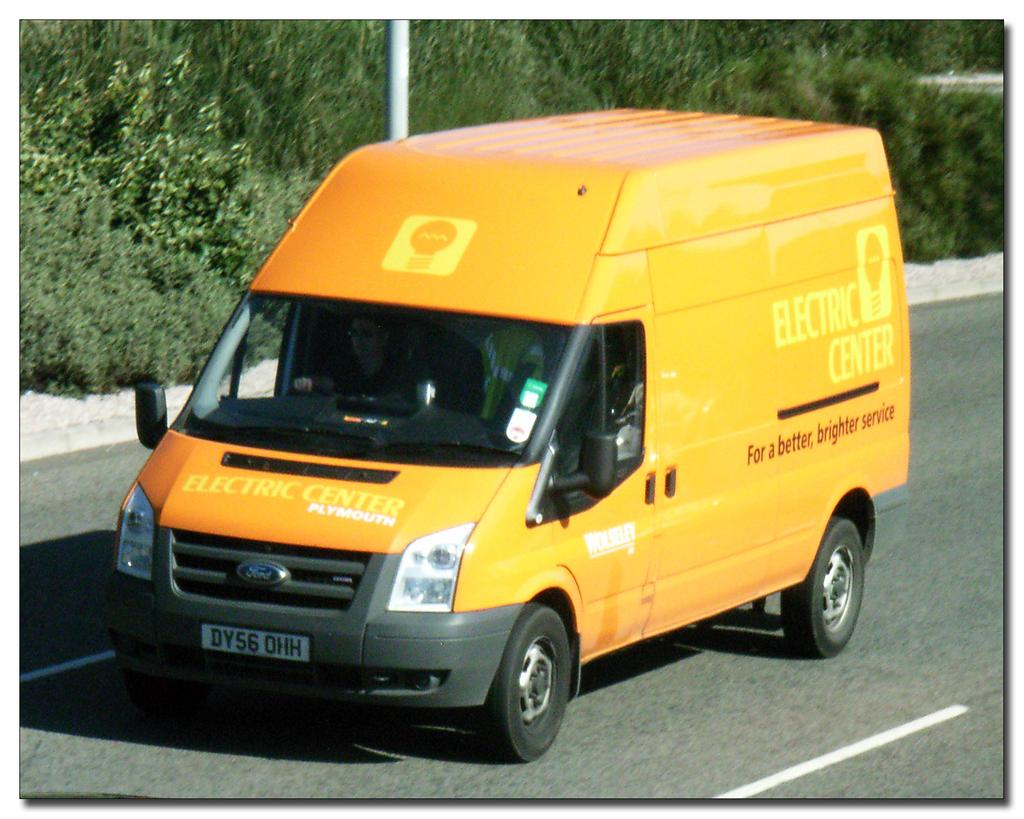Provide a one-sentence caption for the provided image. the word electric that is on a yellow van. 